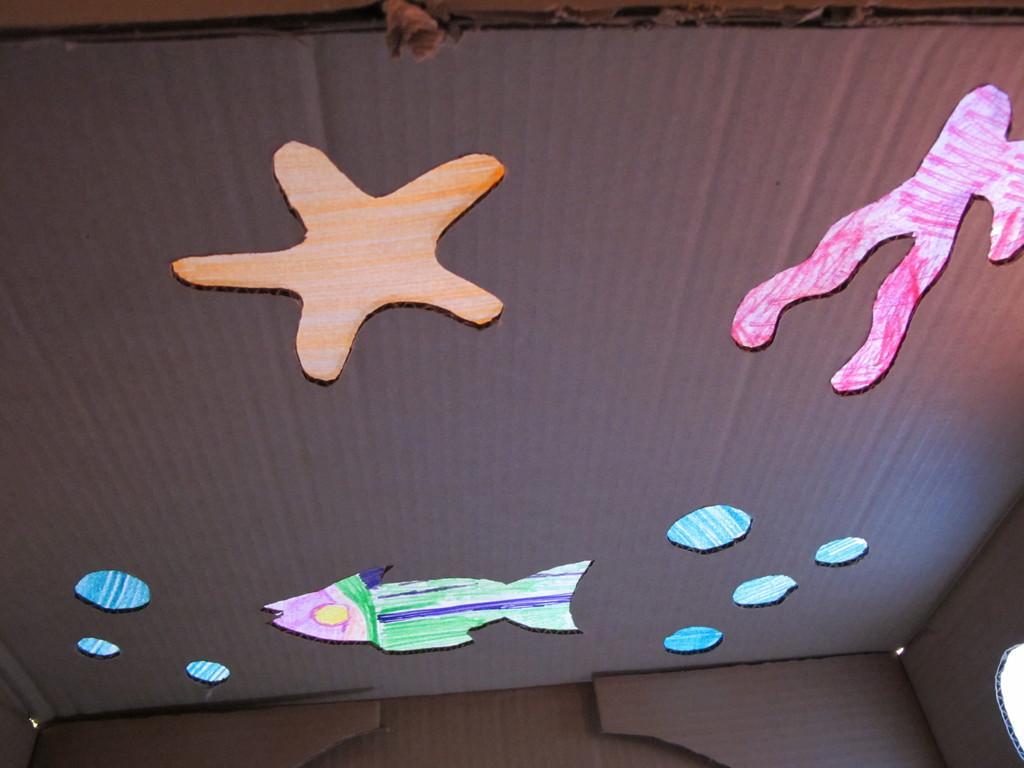In one or two sentences, can you explain what this image depicts? In this image there is a cardboard box having few paper cuttings of a star and a fish are attached to it. 